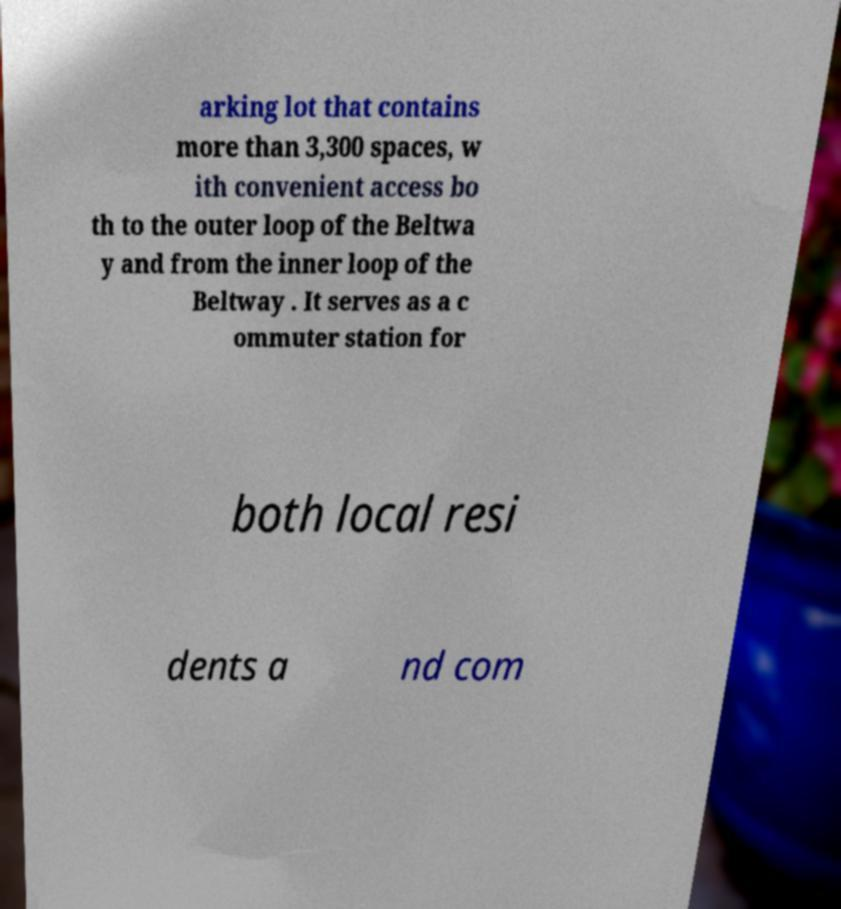There's text embedded in this image that I need extracted. Can you transcribe it verbatim? arking lot that contains more than 3,300 spaces, w ith convenient access bo th to the outer loop of the Beltwa y and from the inner loop of the Beltway . It serves as a c ommuter station for both local resi dents a nd com 